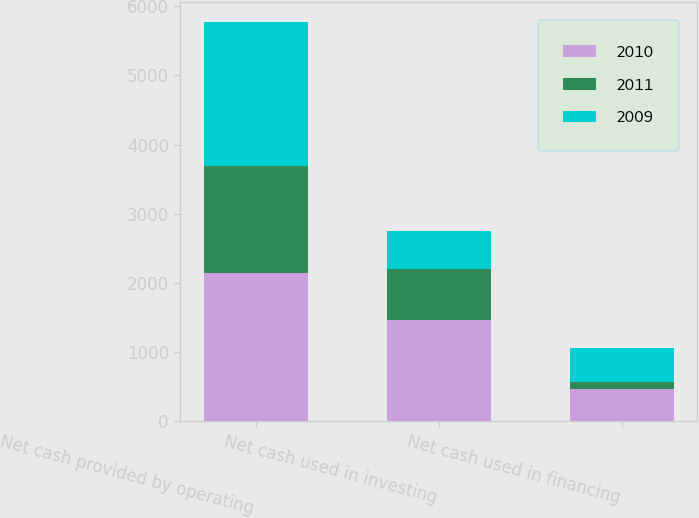Convert chart. <chart><loc_0><loc_0><loc_500><loc_500><stacked_bar_chart><ecel><fcel>Net cash provided by operating<fcel>Net cash used in investing<fcel>Net cash used in financing<nl><fcel>2010<fcel>2143<fcel>1458<fcel>464<nl><fcel>2011<fcel>1542<fcel>743<fcel>102<nl><fcel>2009<fcel>2095<fcel>552<fcel>491<nl></chart> 